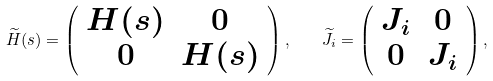<formula> <loc_0><loc_0><loc_500><loc_500>\widetilde { H } ( s ) = \left ( \begin{array} { c c } H ( s ) & 0 \\ 0 & H ( s ) \end{array} \right ) , \quad \widetilde { J } _ { i } = \left ( \begin{array} { c c } J _ { i } & 0 \\ 0 & J _ { i } \end{array} \right ) ,</formula> 